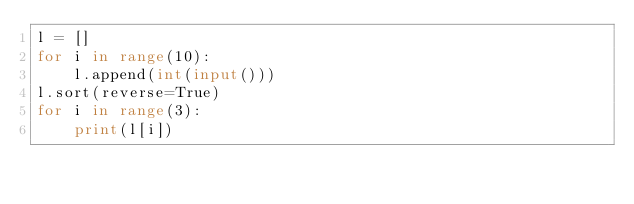<code> <loc_0><loc_0><loc_500><loc_500><_Python_>l = []
for i in range(10):
    l.append(int(input()))
l.sort(reverse=True)
for i in range(3):
    print(l[i])
</code> 